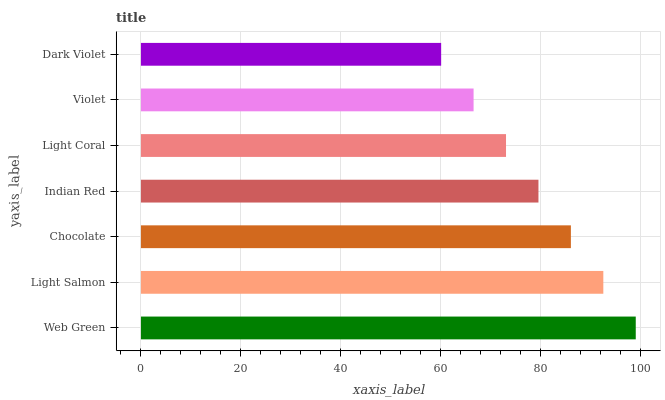Is Dark Violet the minimum?
Answer yes or no. Yes. Is Web Green the maximum?
Answer yes or no. Yes. Is Light Salmon the minimum?
Answer yes or no. No. Is Light Salmon the maximum?
Answer yes or no. No. Is Web Green greater than Light Salmon?
Answer yes or no. Yes. Is Light Salmon less than Web Green?
Answer yes or no. Yes. Is Light Salmon greater than Web Green?
Answer yes or no. No. Is Web Green less than Light Salmon?
Answer yes or no. No. Is Indian Red the high median?
Answer yes or no. Yes. Is Indian Red the low median?
Answer yes or no. Yes. Is Light Coral the high median?
Answer yes or no. No. Is Web Green the low median?
Answer yes or no. No. 